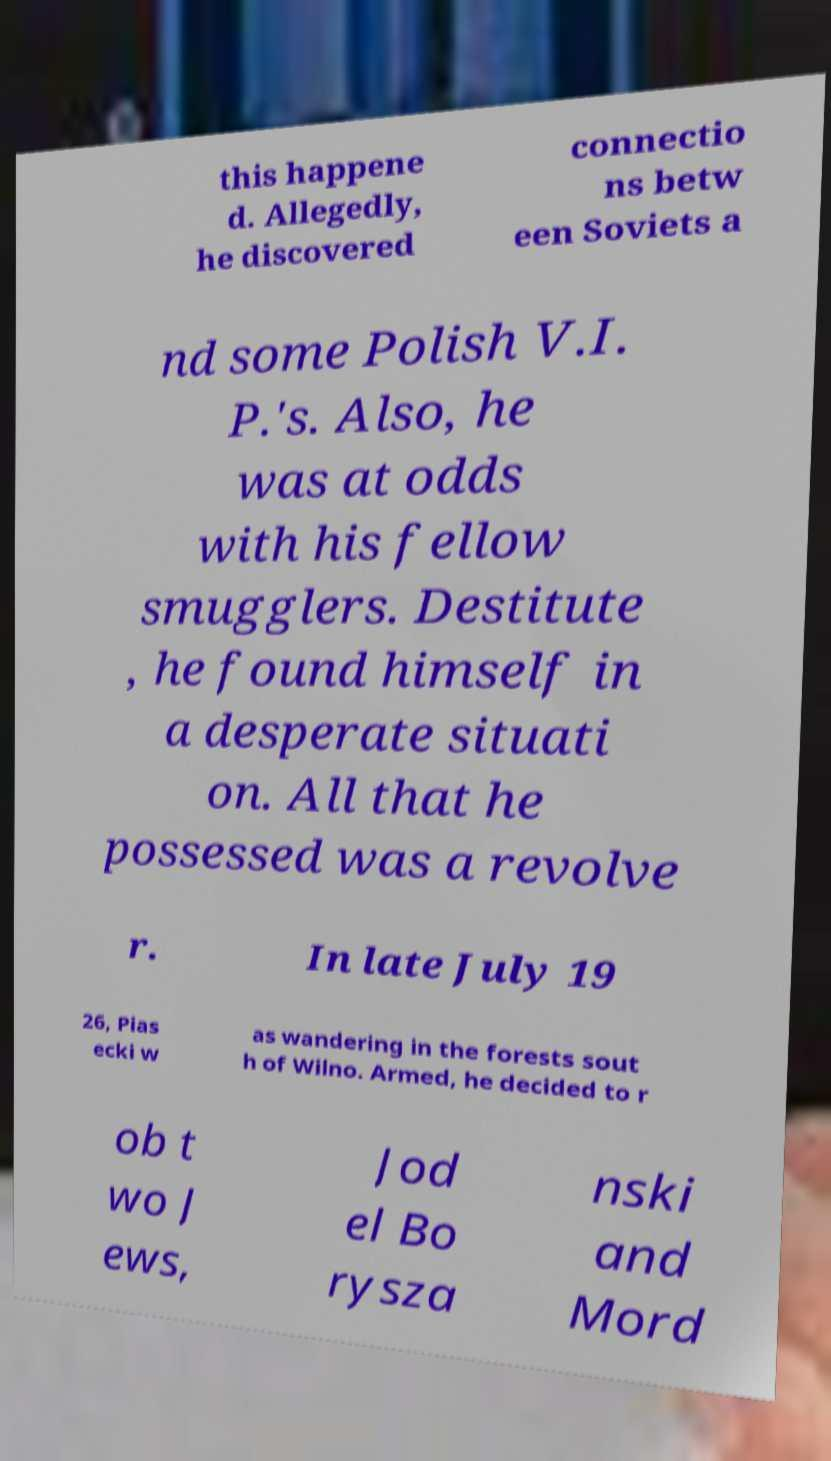Could you assist in decoding the text presented in this image and type it out clearly? this happene d. Allegedly, he discovered connectio ns betw een Soviets a nd some Polish V.I. P.'s. Also, he was at odds with his fellow smugglers. Destitute , he found himself in a desperate situati on. All that he possessed was a revolve r. In late July 19 26, Pias ecki w as wandering in the forests sout h of Wilno. Armed, he decided to r ob t wo J ews, Jod el Bo rysza nski and Mord 